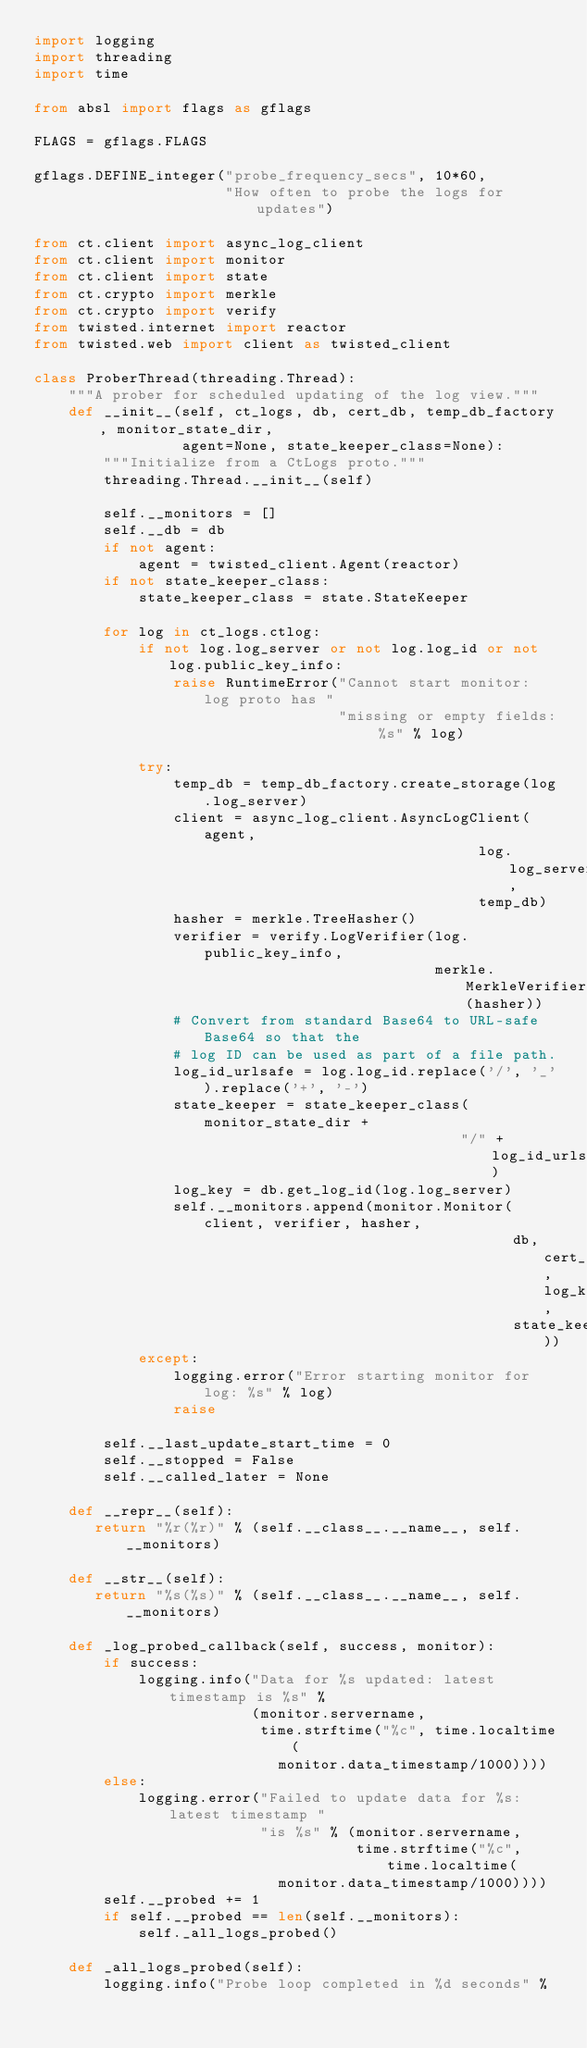<code> <loc_0><loc_0><loc_500><loc_500><_Python_>import logging
import threading
import time

from absl import flags as gflags

FLAGS = gflags.FLAGS

gflags.DEFINE_integer("probe_frequency_secs", 10*60,
                      "How often to probe the logs for updates")

from ct.client import async_log_client
from ct.client import monitor
from ct.client import state
from ct.crypto import merkle
from ct.crypto import verify
from twisted.internet import reactor
from twisted.web import client as twisted_client

class ProberThread(threading.Thread):
    """A prober for scheduled updating of the log view."""
    def __init__(self, ct_logs, db, cert_db, temp_db_factory, monitor_state_dir,
                 agent=None, state_keeper_class=None):
        """Initialize from a CtLogs proto."""
        threading.Thread.__init__(self)

        self.__monitors = []
        self.__db = db
        if not agent:
            agent = twisted_client.Agent(reactor)
        if not state_keeper_class:
            state_keeper_class = state.StateKeeper

        for log in ct_logs.ctlog:
            if not log.log_server or not log.log_id or not log.public_key_info:
                raise RuntimeError("Cannot start monitor: log proto has "
                                   "missing or empty fields: %s" % log)

            try:
                temp_db = temp_db_factory.create_storage(log.log_server)
                client = async_log_client.AsyncLogClient(agent,
                                                   log.log_server,
                                                   temp_db)
                hasher = merkle.TreeHasher()
                verifier = verify.LogVerifier(log.public_key_info,
                                              merkle.MerkleVerifier(hasher))
                # Convert from standard Base64 to URL-safe Base64 so that the
                # log ID can be used as part of a file path.
                log_id_urlsafe = log.log_id.replace('/', '_').replace('+', '-')
                state_keeper = state_keeper_class(monitor_state_dir +
                                                 "/" + log_id_urlsafe)
                log_key = db.get_log_id(log.log_server)
                self.__monitors.append(monitor.Monitor(client, verifier, hasher,
                                                       db, cert_db, log_key,
                                                       state_keeper))
            except:
                logging.error("Error starting monitor for log: %s" % log)
                raise

        self.__last_update_start_time = 0
        self.__stopped = False
        self.__called_later = None

    def __repr__(self):
       return "%r(%r)" % (self.__class__.__name__, self.__monitors)

    def __str__(self):
       return "%s(%s)" % (self.__class__.__name__, self.__monitors)

    def _log_probed_callback(self, success, monitor):
        if success:
            logging.info("Data for %s updated: latest timestamp is %s" %
                         (monitor.servername,
                          time.strftime("%c", time.localtime(
                            monitor.data_timestamp/1000))))
        else:
            logging.error("Failed to update data for %s: latest timestamp "
                          "is %s" % (monitor.servername,
                                     time.strftime("%c", time.localtime(
                            monitor.data_timestamp/1000))))
        self.__probed += 1
        if self.__probed == len(self.__monitors):
            self._all_logs_probed()

    def _all_logs_probed(self):
        logging.info("Probe loop completed in %d seconds" %</code> 